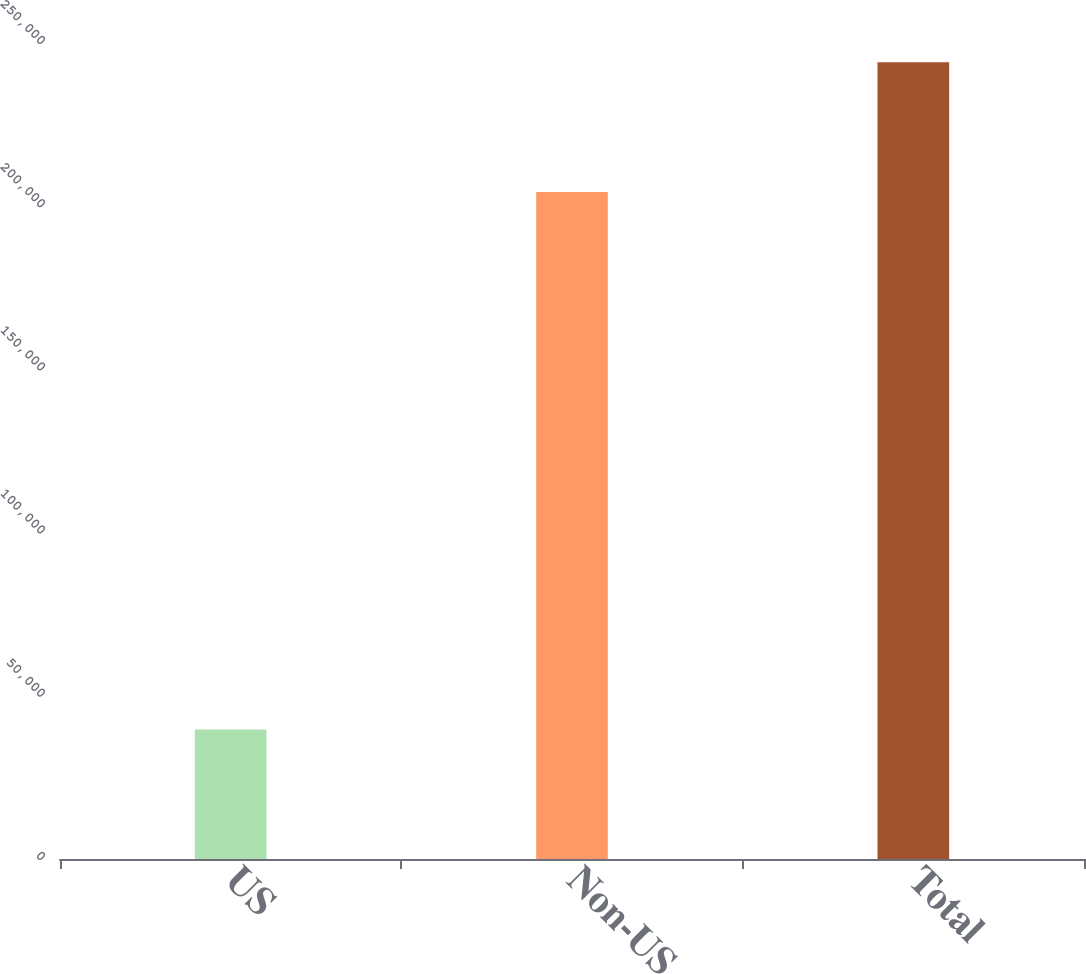Convert chart. <chart><loc_0><loc_0><loc_500><loc_500><bar_chart><fcel>US<fcel>Non-US<fcel>Total<nl><fcel>39689<fcel>204379<fcel>244068<nl></chart> 